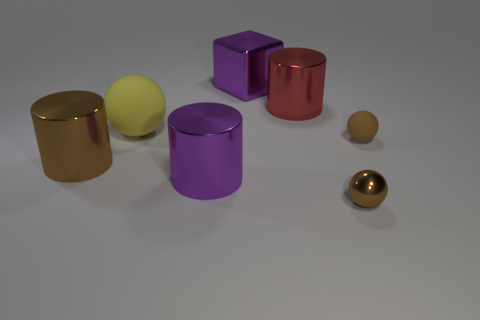There is a matte object to the left of the purple metallic cylinder; is its shape the same as the large purple thing that is behind the purple cylinder?
Keep it short and to the point. No. What number of objects are purple rubber objects or big metal cylinders?
Provide a short and direct response. 3. There is a block that is the same size as the yellow matte ball; what is its color?
Your answer should be compact. Purple. How many red shiny objects are in front of the large ball that is behind the large brown thing?
Give a very brief answer. 0. How many objects are both right of the brown metal cylinder and on the left side of the small matte ball?
Offer a terse response. 5. How many objects are matte balls that are behind the tiny rubber ball or rubber balls to the left of the purple cylinder?
Give a very brief answer. 1. How many other objects are there of the same size as the metal ball?
Provide a succinct answer. 1. There is a large red thing that is behind the small brown ball that is in front of the brown cylinder; what shape is it?
Give a very brief answer. Cylinder. Does the large thing behind the red thing have the same color as the small sphere that is in front of the brown matte thing?
Keep it short and to the point. No. Is there any other thing that has the same color as the small shiny object?
Offer a terse response. Yes. 